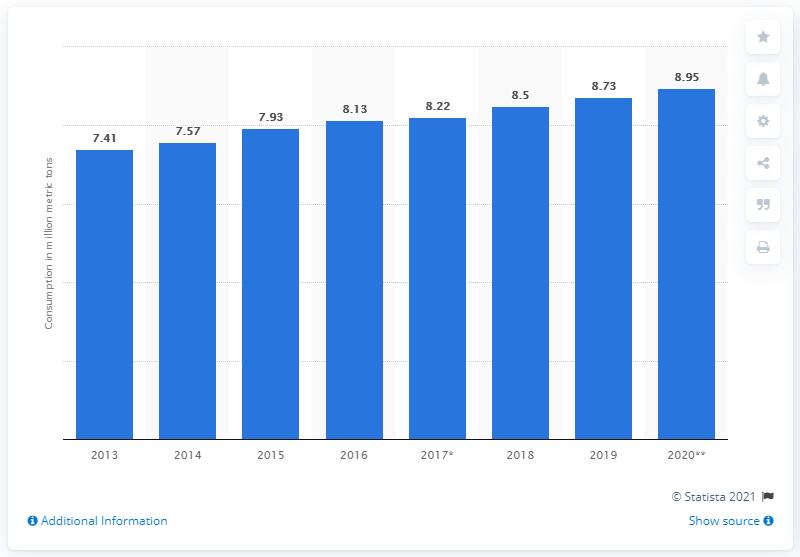Outline some significant characteristics in this image. In 2019, the consumption of meat in Mexico was 8.95. 